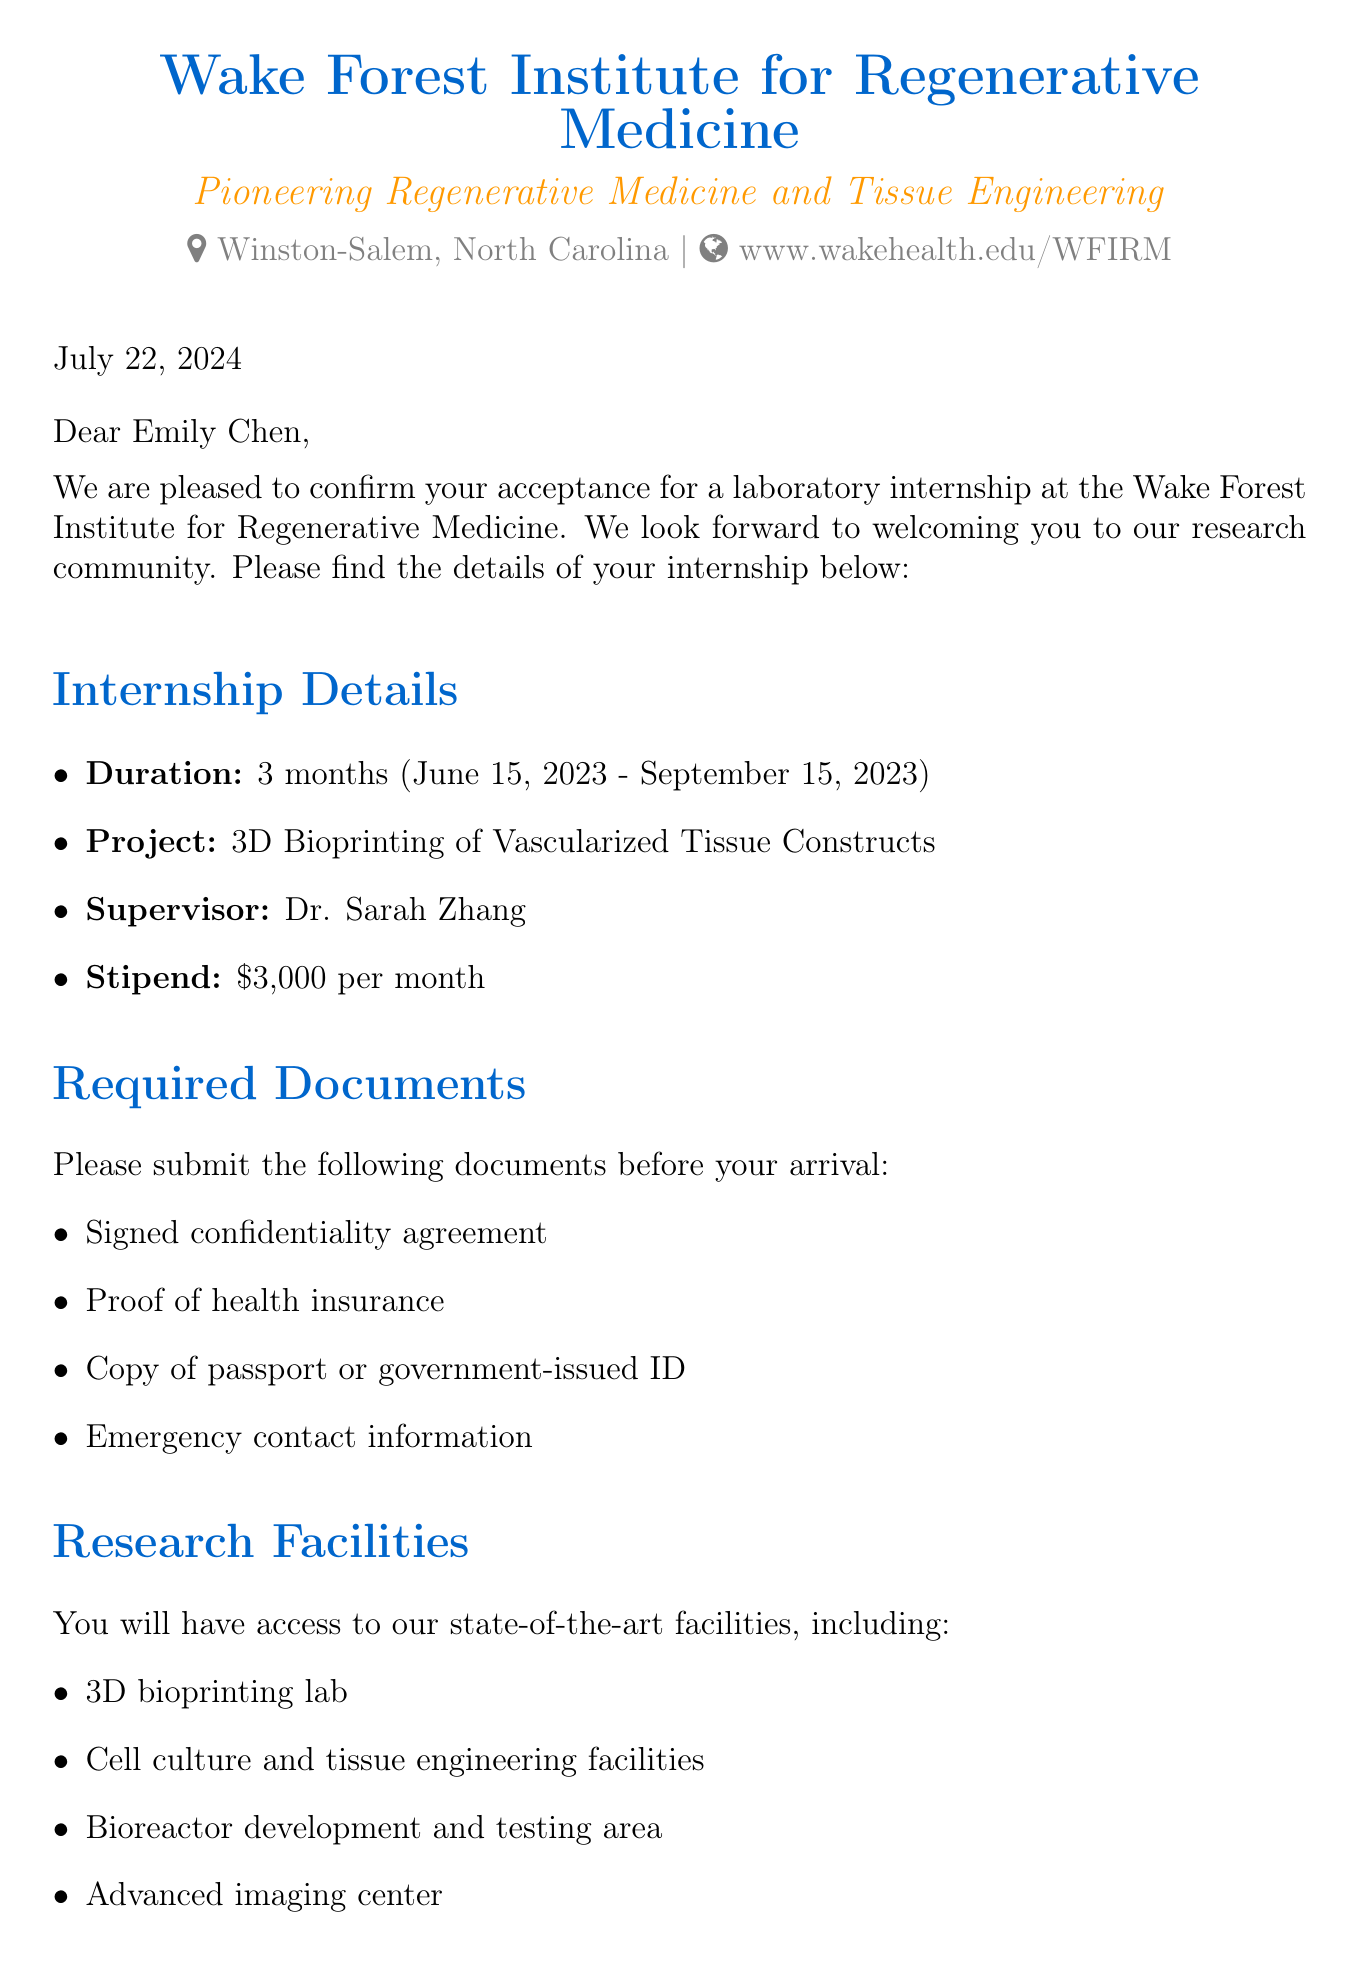What is the name of the institute? The name of the institute is explicitly mentioned in the document as the Wake Forest Institute for Regenerative Medicine.
Answer: Wake Forest Institute for Regenerative Medicine Who is the project supervisor? The document states that Dr. Sarah Zhang is the supervisor for the internship project.
Answer: Dr. Sarah Zhang What is the stipend amount? The stipend amount is listed as $3,000 per month in the internship details.
Answer: $3,000 How long is the internship duration? The document specifies that the internship duration is 3 months.
Answer: 3 months What is the project focus of the internship? The project focus for the internship is outlined as 3D Bioprinting of Vascularized Tissue Constructs.
Answer: 3D Bioprinting of Vascularized Tissue Constructs What document is required for health insurance? The document explicitly mentions that proof of health insurance is required before arrival.
Answer: Proof of health insurance Which airport is nearest to the institute? The nearest airport mentioned in the document is Piedmont Triad International Airport (GSO).
Answer: Piedmont Triad International Airport (GSO) What type of housing options are available? The document lists on-campus graduate student housing and off-campus apartment rentals as available options.
Answer: On-campus graduate student housing or off-campus apartment rentals What is one expected outcome of the internship? The document provides multiple expected outcomes, one of which is gaining hands-on experience in 3D bioprinting techniques.
Answer: Gain hands-on experience in 3D bioprinting techniques 